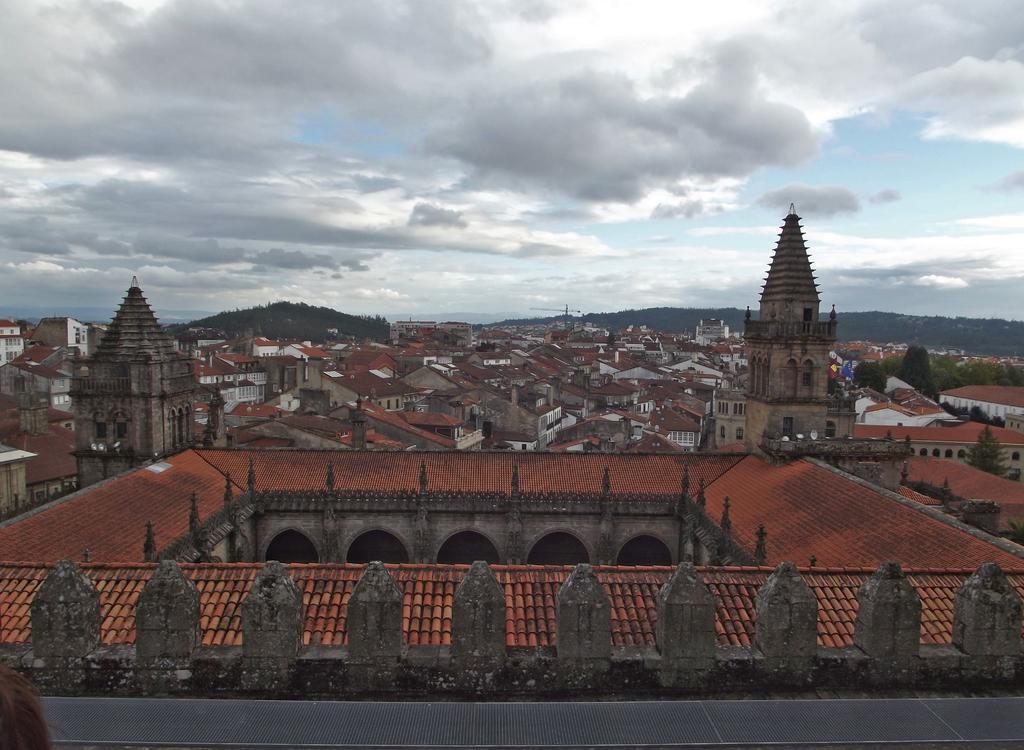Could you give a brief overview of what you see in this image? There are buildings which are having roofs and there are mountains on the ground. In the background, there are clouds in the blue sky. 